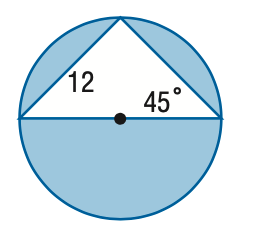Answer the mathemtical geometry problem and directly provide the correct option letter.
Question: Find the area of the shaded region. Round to the nearest tenth.
Choices: A: 41.1 B: 82.2 C: 154.2 D: 267.3 C 